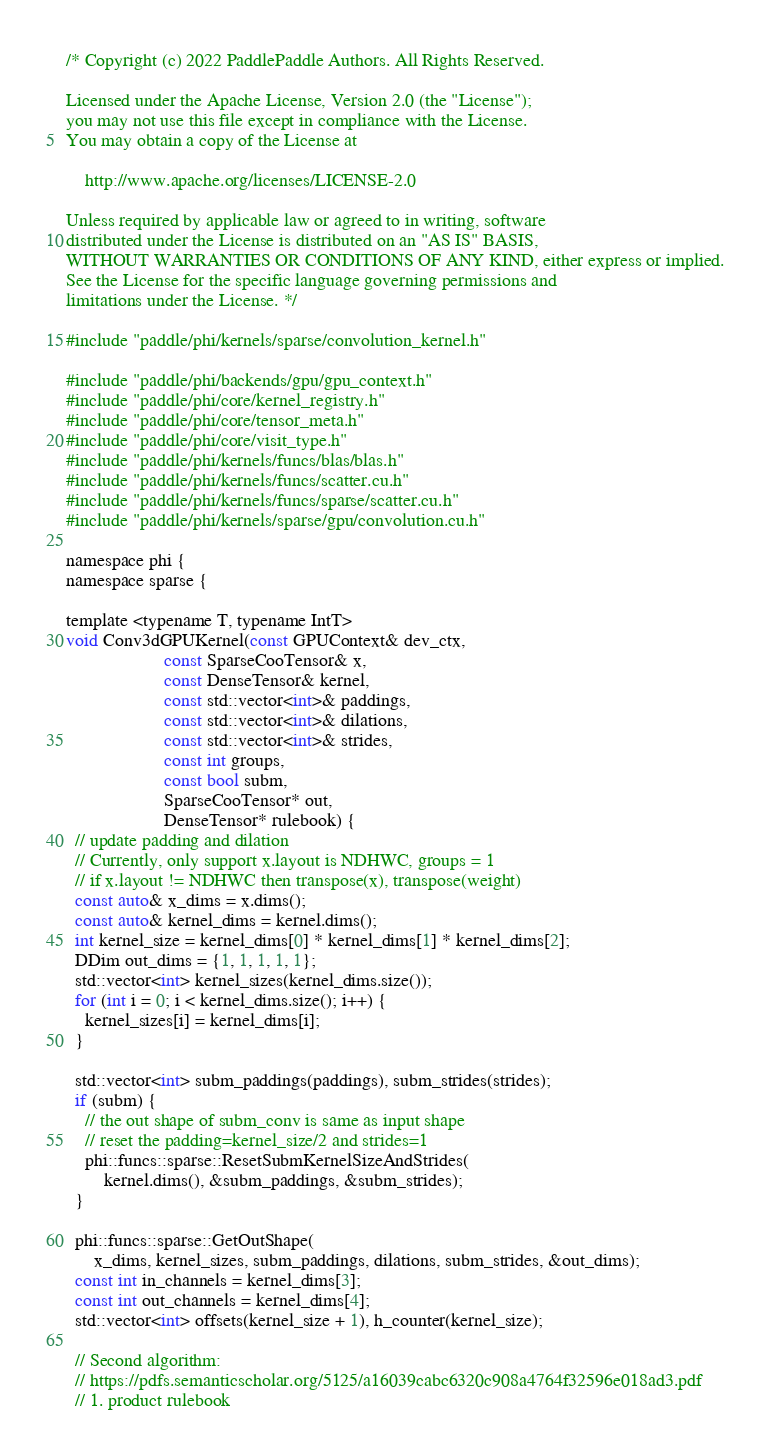Convert code to text. <code><loc_0><loc_0><loc_500><loc_500><_Cuda_>/* Copyright (c) 2022 PaddlePaddle Authors. All Rights Reserved.

Licensed under the Apache License, Version 2.0 (the "License");
you may not use this file except in compliance with the License.
You may obtain a copy of the License at

    http://www.apache.org/licenses/LICENSE-2.0

Unless required by applicable law or agreed to in writing, software
distributed under the License is distributed on an "AS IS" BASIS,
WITHOUT WARRANTIES OR CONDITIONS OF ANY KIND, either express or implied.
See the License for the specific language governing permissions and
limitations under the License. */

#include "paddle/phi/kernels/sparse/convolution_kernel.h"

#include "paddle/phi/backends/gpu/gpu_context.h"
#include "paddle/phi/core/kernel_registry.h"
#include "paddle/phi/core/tensor_meta.h"
#include "paddle/phi/core/visit_type.h"
#include "paddle/phi/kernels/funcs/blas/blas.h"
#include "paddle/phi/kernels/funcs/scatter.cu.h"
#include "paddle/phi/kernels/funcs/sparse/scatter.cu.h"
#include "paddle/phi/kernels/sparse/gpu/convolution.cu.h"

namespace phi {
namespace sparse {

template <typename T, typename IntT>
void Conv3dGPUKernel(const GPUContext& dev_ctx,
                     const SparseCooTensor& x,
                     const DenseTensor& kernel,
                     const std::vector<int>& paddings,
                     const std::vector<int>& dilations,
                     const std::vector<int>& strides,
                     const int groups,
                     const bool subm,
                     SparseCooTensor* out,
                     DenseTensor* rulebook) {
  // update padding and dilation
  // Currently, only support x.layout is NDHWC, groups = 1
  // if x.layout != NDHWC then transpose(x), transpose(weight)
  const auto& x_dims = x.dims();
  const auto& kernel_dims = kernel.dims();
  int kernel_size = kernel_dims[0] * kernel_dims[1] * kernel_dims[2];
  DDim out_dims = {1, 1, 1, 1, 1};
  std::vector<int> kernel_sizes(kernel_dims.size());
  for (int i = 0; i < kernel_dims.size(); i++) {
    kernel_sizes[i] = kernel_dims[i];
  }

  std::vector<int> subm_paddings(paddings), subm_strides(strides);
  if (subm) {
    // the out shape of subm_conv is same as input shape
    // reset the padding=kernel_size/2 and strides=1
    phi::funcs::sparse::ResetSubmKernelSizeAndStrides(
        kernel.dims(), &subm_paddings, &subm_strides);
  }

  phi::funcs::sparse::GetOutShape(
      x_dims, kernel_sizes, subm_paddings, dilations, subm_strides, &out_dims);
  const int in_channels = kernel_dims[3];
  const int out_channels = kernel_dims[4];
  std::vector<int> offsets(kernel_size + 1), h_counter(kernel_size);

  // Second algorithm:
  // https://pdfs.semanticscholar.org/5125/a16039cabc6320c908a4764f32596e018ad3.pdf
  // 1. product rulebook</code> 